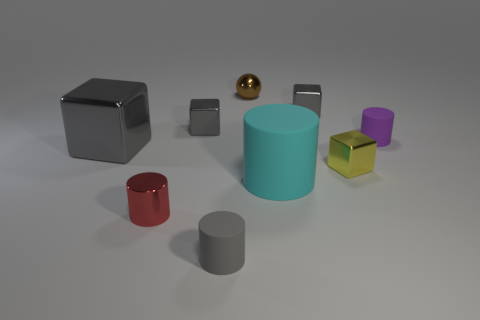Subtract all gray blocks. How many were subtracted if there are1gray blocks left? 2 Subtract all brown cylinders. How many gray blocks are left? 3 Add 1 small shiny cubes. How many objects exist? 10 Subtract all cylinders. How many objects are left? 5 Add 3 tiny red metal cylinders. How many tiny red metal cylinders are left? 4 Add 1 small yellow cubes. How many small yellow cubes exist? 2 Subtract 0 green cylinders. How many objects are left? 9 Subtract all gray cubes. Subtract all cyan cylinders. How many objects are left? 5 